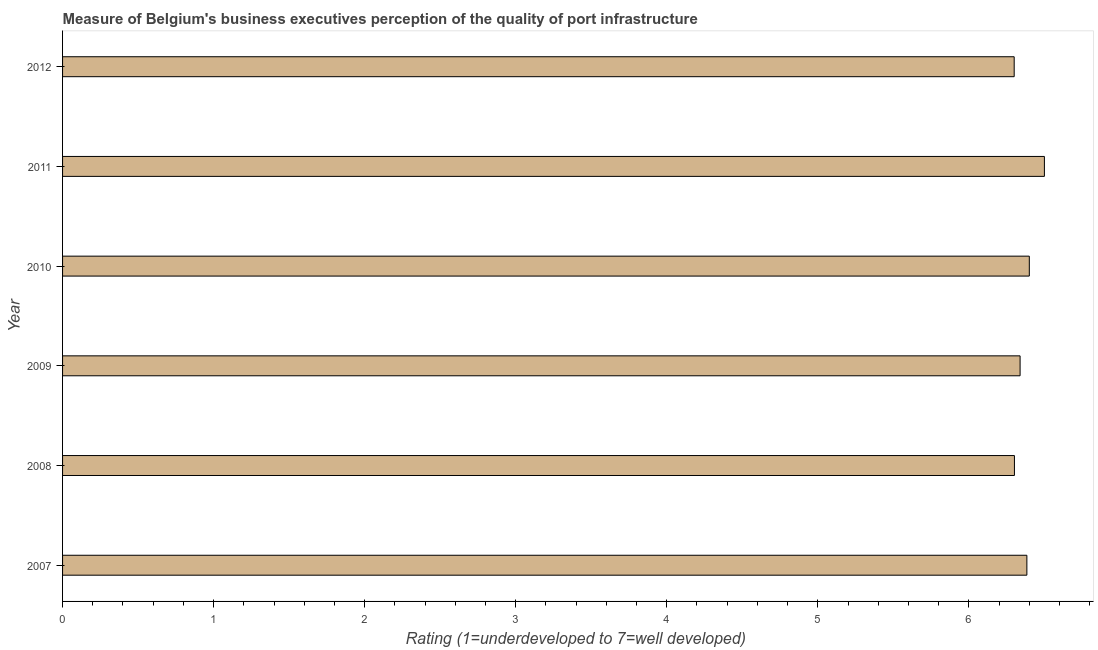Does the graph contain grids?
Keep it short and to the point. No. What is the title of the graph?
Offer a very short reply. Measure of Belgium's business executives perception of the quality of port infrastructure. What is the label or title of the X-axis?
Make the answer very short. Rating (1=underdeveloped to 7=well developed) . What is the label or title of the Y-axis?
Make the answer very short. Year. What is the rating measuring quality of port infrastructure in 2010?
Provide a short and direct response. 6.4. Across all years, what is the minimum rating measuring quality of port infrastructure?
Offer a terse response. 6.3. What is the sum of the rating measuring quality of port infrastructure?
Provide a succinct answer. 38.22. What is the difference between the rating measuring quality of port infrastructure in 2008 and 2010?
Provide a succinct answer. -0.1. What is the average rating measuring quality of port infrastructure per year?
Offer a very short reply. 6.37. What is the median rating measuring quality of port infrastructure?
Keep it short and to the point. 6.36. Do a majority of the years between 2009 and 2011 (inclusive) have rating measuring quality of port infrastructure greater than 4.8 ?
Ensure brevity in your answer.  Yes. Is the rating measuring quality of port infrastructure in 2008 less than that in 2010?
Ensure brevity in your answer.  Yes. Is the difference between the rating measuring quality of port infrastructure in 2009 and 2012 greater than the difference between any two years?
Give a very brief answer. No. How many bars are there?
Your response must be concise. 6. What is the Rating (1=underdeveloped to 7=well developed)  in 2007?
Provide a short and direct response. 6.38. What is the Rating (1=underdeveloped to 7=well developed)  in 2008?
Your response must be concise. 6.3. What is the Rating (1=underdeveloped to 7=well developed)  of 2009?
Your answer should be compact. 6.34. What is the Rating (1=underdeveloped to 7=well developed)  of 2010?
Keep it short and to the point. 6.4. What is the Rating (1=underdeveloped to 7=well developed)  in 2011?
Your response must be concise. 6.5. What is the Rating (1=underdeveloped to 7=well developed)  in 2012?
Ensure brevity in your answer.  6.3. What is the difference between the Rating (1=underdeveloped to 7=well developed)  in 2007 and 2008?
Give a very brief answer. 0.08. What is the difference between the Rating (1=underdeveloped to 7=well developed)  in 2007 and 2009?
Provide a succinct answer. 0.04. What is the difference between the Rating (1=underdeveloped to 7=well developed)  in 2007 and 2010?
Offer a very short reply. -0.02. What is the difference between the Rating (1=underdeveloped to 7=well developed)  in 2007 and 2011?
Ensure brevity in your answer.  -0.12. What is the difference between the Rating (1=underdeveloped to 7=well developed)  in 2007 and 2012?
Keep it short and to the point. 0.08. What is the difference between the Rating (1=underdeveloped to 7=well developed)  in 2008 and 2009?
Give a very brief answer. -0.04. What is the difference between the Rating (1=underdeveloped to 7=well developed)  in 2008 and 2010?
Your response must be concise. -0.1. What is the difference between the Rating (1=underdeveloped to 7=well developed)  in 2008 and 2011?
Your answer should be compact. -0.2. What is the difference between the Rating (1=underdeveloped to 7=well developed)  in 2008 and 2012?
Provide a succinct answer. 0. What is the difference between the Rating (1=underdeveloped to 7=well developed)  in 2009 and 2010?
Provide a succinct answer. -0.06. What is the difference between the Rating (1=underdeveloped to 7=well developed)  in 2009 and 2011?
Give a very brief answer. -0.16. What is the difference between the Rating (1=underdeveloped to 7=well developed)  in 2009 and 2012?
Your response must be concise. 0.04. What is the difference between the Rating (1=underdeveloped to 7=well developed)  in 2010 and 2011?
Provide a short and direct response. -0.1. What is the difference between the Rating (1=underdeveloped to 7=well developed)  in 2010 and 2012?
Offer a very short reply. 0.1. What is the ratio of the Rating (1=underdeveloped to 7=well developed)  in 2007 to that in 2008?
Give a very brief answer. 1.01. What is the ratio of the Rating (1=underdeveloped to 7=well developed)  in 2007 to that in 2009?
Make the answer very short. 1.01. What is the ratio of the Rating (1=underdeveloped to 7=well developed)  in 2007 to that in 2012?
Your answer should be very brief. 1.01. What is the ratio of the Rating (1=underdeveloped to 7=well developed)  in 2009 to that in 2010?
Ensure brevity in your answer.  0.99. What is the ratio of the Rating (1=underdeveloped to 7=well developed)  in 2009 to that in 2011?
Provide a short and direct response. 0.97. What is the ratio of the Rating (1=underdeveloped to 7=well developed)  in 2009 to that in 2012?
Your response must be concise. 1.01. What is the ratio of the Rating (1=underdeveloped to 7=well developed)  in 2010 to that in 2012?
Ensure brevity in your answer.  1.02. What is the ratio of the Rating (1=underdeveloped to 7=well developed)  in 2011 to that in 2012?
Offer a terse response. 1.03. 